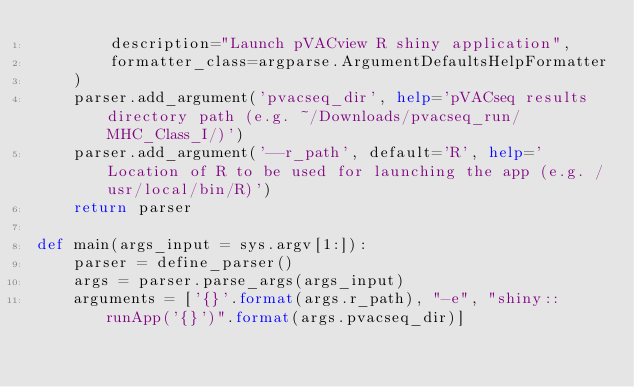<code> <loc_0><loc_0><loc_500><loc_500><_Python_>        description="Launch pVACview R shiny application",
        formatter_class=argparse.ArgumentDefaultsHelpFormatter
    )
    parser.add_argument('pvacseq_dir', help='pVACseq results directory path (e.g. ~/Downloads/pvacseq_run/MHC_Class_I/)')
    parser.add_argument('--r_path', default='R', help='Location of R to be used for launching the app (e.g. /usr/local/bin/R)')
    return parser

def main(args_input = sys.argv[1:]):
    parser = define_parser()
    args = parser.parse_args(args_input)
    arguments = ['{}'.format(args.r_path), "-e", "shiny::runApp('{}')".format(args.pvacseq_dir)]</code> 